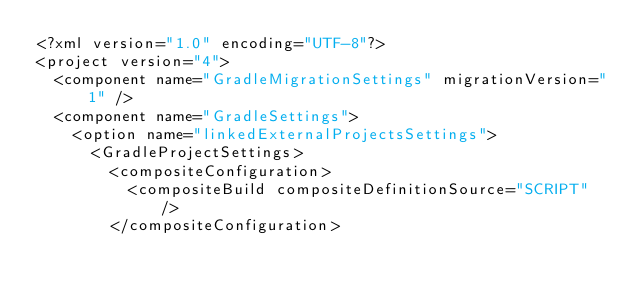<code> <loc_0><loc_0><loc_500><loc_500><_XML_><?xml version="1.0" encoding="UTF-8"?>
<project version="4">
  <component name="GradleMigrationSettings" migrationVersion="1" />
  <component name="GradleSettings">
    <option name="linkedExternalProjectsSettings">
      <GradleProjectSettings>
        <compositeConfiguration>
          <compositeBuild compositeDefinitionSource="SCRIPT" />
        </compositeConfiguration></code> 